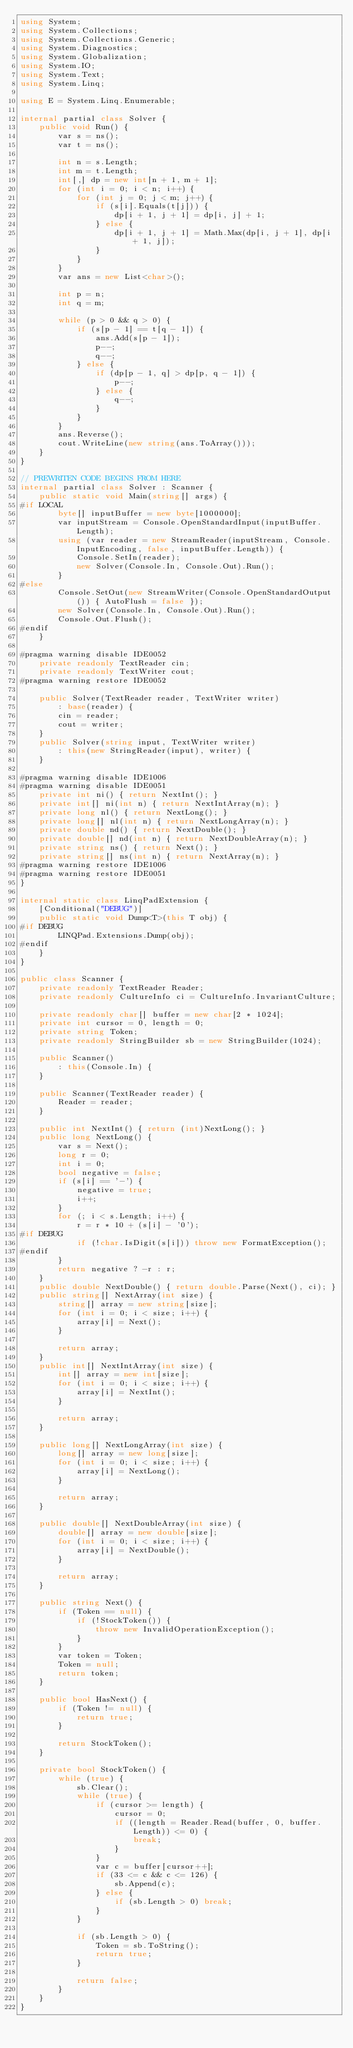<code> <loc_0><loc_0><loc_500><loc_500><_C#_>using System;
using System.Collections;
using System.Collections.Generic;
using System.Diagnostics;
using System.Globalization;
using System.IO;
using System.Text;
using System.Linq;

using E = System.Linq.Enumerable;

internal partial class Solver {
    public void Run() {
        var s = ns();
        var t = ns();

        int n = s.Length;
        int m = t.Length;
        int[,] dp = new int[n + 1, m + 1];
        for (int i = 0; i < n; i++) {
            for (int j = 0; j < m; j++) {
                if (s[i].Equals(t[j])) {
                    dp[i + 1, j + 1] = dp[i, j] + 1;
                } else {
                    dp[i + 1, j + 1] = Math.Max(dp[i, j + 1], dp[i + 1, j]);
                }
            }
        }
        var ans = new List<char>();

        int p = n;
        int q = m;

        while (p > 0 && q > 0) {
            if (s[p - 1] == t[q - 1]) {
                ans.Add(s[p - 1]);
                p--;
                q--;
            } else {
                if (dp[p - 1, q] > dp[p, q - 1]) {
                    p--;
                } else {
                    q--;
                }
            }
        }
        ans.Reverse();
        cout.WriteLine(new string(ans.ToArray()));
    }
}

// PREWRITEN CODE BEGINS FROM HERE
internal partial class Solver : Scanner {
    public static void Main(string[] args) {
#if LOCAL
        byte[] inputBuffer = new byte[1000000];
        var inputStream = Console.OpenStandardInput(inputBuffer.Length);
        using (var reader = new StreamReader(inputStream, Console.InputEncoding, false, inputBuffer.Length)) {
            Console.SetIn(reader);
            new Solver(Console.In, Console.Out).Run();
        }
#else
        Console.SetOut(new StreamWriter(Console.OpenStandardOutput()) { AutoFlush = false });
        new Solver(Console.In, Console.Out).Run();
        Console.Out.Flush();
#endif
    }

#pragma warning disable IDE0052
    private readonly TextReader cin;
    private readonly TextWriter cout;
#pragma warning restore IDE0052

    public Solver(TextReader reader, TextWriter writer)
        : base(reader) {
        cin = reader;
        cout = writer;
    }
    public Solver(string input, TextWriter writer)
        : this(new StringReader(input), writer) {
    }

#pragma warning disable IDE1006
#pragma warning disable IDE0051
    private int ni() { return NextInt(); }
    private int[] ni(int n) { return NextIntArray(n); }
    private long nl() { return NextLong(); }
    private long[] nl(int n) { return NextLongArray(n); }
    private double nd() { return NextDouble(); }
    private double[] nd(int n) { return NextDoubleArray(n); }
    private string ns() { return Next(); }
    private string[] ns(int n) { return NextArray(n); }
#pragma warning restore IDE1006
#pragma warning restore IDE0051
}

internal static class LinqPadExtension {
    [Conditional("DEBUG")]
    public static void Dump<T>(this T obj) {
#if DEBUG
        LINQPad.Extensions.Dump(obj);
#endif
    }
}

public class Scanner {
    private readonly TextReader Reader;
    private readonly CultureInfo ci = CultureInfo.InvariantCulture;

    private readonly char[] buffer = new char[2 * 1024];
    private int cursor = 0, length = 0;
    private string Token;
    private readonly StringBuilder sb = new StringBuilder(1024);

    public Scanner()
        : this(Console.In) {
    }

    public Scanner(TextReader reader) {
        Reader = reader;
    }

    public int NextInt() { return (int)NextLong(); }
    public long NextLong() {
        var s = Next();
        long r = 0;
        int i = 0;
        bool negative = false;
        if (s[i] == '-') {
            negative = true;
            i++;
        }
        for (; i < s.Length; i++) {
            r = r * 10 + (s[i] - '0');
#if DEBUG
            if (!char.IsDigit(s[i])) throw new FormatException();
#endif
        }
        return negative ? -r : r;
    }
    public double NextDouble() { return double.Parse(Next(), ci); }
    public string[] NextArray(int size) {
        string[] array = new string[size];
        for (int i = 0; i < size; i++) {
            array[i] = Next();
        }

        return array;
    }
    public int[] NextIntArray(int size) {
        int[] array = new int[size];
        for (int i = 0; i < size; i++) {
            array[i] = NextInt();
        }

        return array;
    }

    public long[] NextLongArray(int size) {
        long[] array = new long[size];
        for (int i = 0; i < size; i++) {
            array[i] = NextLong();
        }

        return array;
    }

    public double[] NextDoubleArray(int size) {
        double[] array = new double[size];
        for (int i = 0; i < size; i++) {
            array[i] = NextDouble();
        }

        return array;
    }

    public string Next() {
        if (Token == null) {
            if (!StockToken()) {
                throw new InvalidOperationException();
            }
        }
        var token = Token;
        Token = null;
        return token;
    }

    public bool HasNext() {
        if (Token != null) {
            return true;
        }

        return StockToken();
    }

    private bool StockToken() {
        while (true) {
            sb.Clear();
            while (true) {
                if (cursor >= length) {
                    cursor = 0;
                    if ((length = Reader.Read(buffer, 0, buffer.Length)) <= 0) {
                        break;
                    }
                }
                var c = buffer[cursor++];
                if (33 <= c && c <= 126) {
                    sb.Append(c);
                } else {
                    if (sb.Length > 0) break;
                }
            }

            if (sb.Length > 0) {
                Token = sb.ToString();
                return true;
            }

            return false;
        }
    }
}</code> 